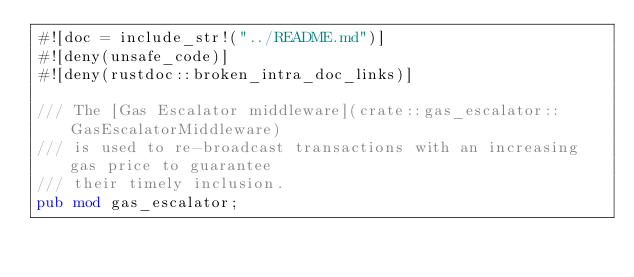<code> <loc_0><loc_0><loc_500><loc_500><_Rust_>#![doc = include_str!("../README.md")]
#![deny(unsafe_code)]
#![deny(rustdoc::broken_intra_doc_links)]

/// The [Gas Escalator middleware](crate::gas_escalator::GasEscalatorMiddleware)
/// is used to re-broadcast transactions with an increasing gas price to guarantee
/// their timely inclusion.
pub mod gas_escalator;
</code> 